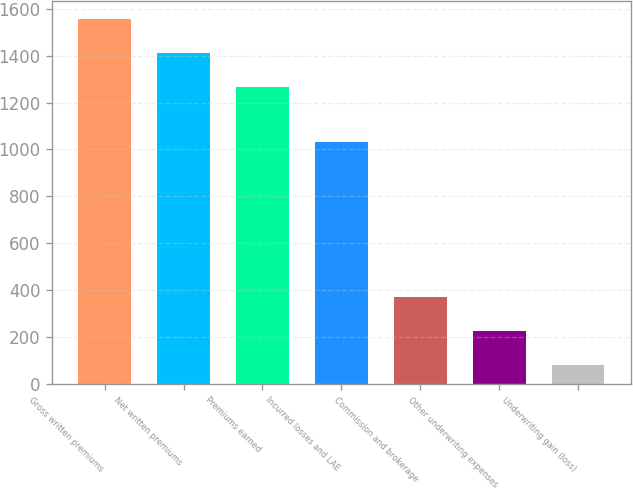Convert chart. <chart><loc_0><loc_0><loc_500><loc_500><bar_chart><fcel>Gross written premiums<fcel>Net written premiums<fcel>Premiums earned<fcel>Incurred losses and LAE<fcel>Commission and brokerage<fcel>Other underwriting expenses<fcel>Underwriting gain (loss)<nl><fcel>1557.26<fcel>1411.98<fcel>1266.7<fcel>1033.3<fcel>370.06<fcel>224.78<fcel>79.5<nl></chart> 